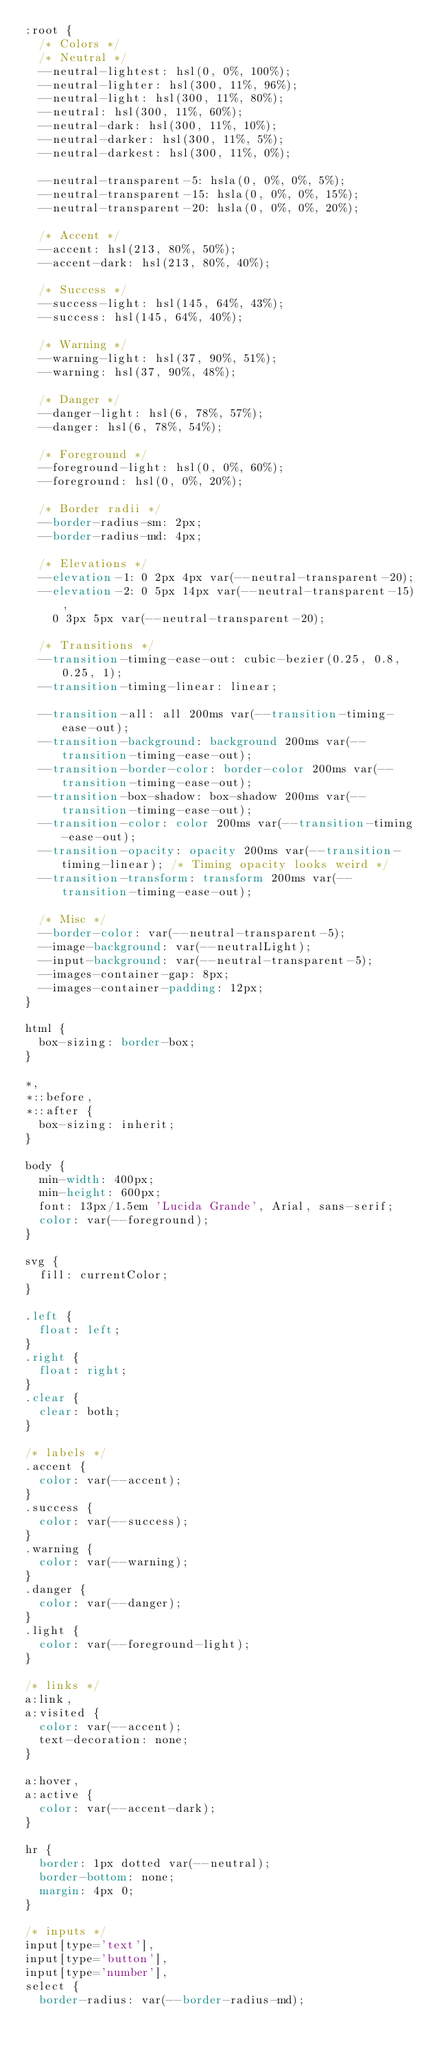Convert code to text. <code><loc_0><loc_0><loc_500><loc_500><_CSS_>:root {
  /* Colors */
  /* Neutral */
  --neutral-lightest: hsl(0, 0%, 100%);
  --neutral-lighter: hsl(300, 11%, 96%);
  --neutral-light: hsl(300, 11%, 80%);
  --neutral: hsl(300, 11%, 60%);
  --neutral-dark: hsl(300, 11%, 10%);
  --neutral-darker: hsl(300, 11%, 5%);
  --neutral-darkest: hsl(300, 11%, 0%);

  --neutral-transparent-5: hsla(0, 0%, 0%, 5%);
  --neutral-transparent-15: hsla(0, 0%, 0%, 15%);
  --neutral-transparent-20: hsla(0, 0%, 0%, 20%);

  /* Accent */
  --accent: hsl(213, 80%, 50%);
  --accent-dark: hsl(213, 80%, 40%);

  /* Success */
  --success-light: hsl(145, 64%, 43%);
  --success: hsl(145, 64%, 40%);

  /* Warning */
  --warning-light: hsl(37, 90%, 51%);
  --warning: hsl(37, 90%, 48%);

  /* Danger */
  --danger-light: hsl(6, 78%, 57%);
  --danger: hsl(6, 78%, 54%);

  /* Foreground */
  --foreground-light: hsl(0, 0%, 60%);
  --foreground: hsl(0, 0%, 20%);

  /* Border radii */
  --border-radius-sm: 2px;
  --border-radius-md: 4px;

  /* Elevations */
  --elevation-1: 0 2px 4px var(--neutral-transparent-20);
  --elevation-2: 0 5px 14px var(--neutral-transparent-15),
    0 3px 5px var(--neutral-transparent-20);

  /* Transitions */
  --transition-timing-ease-out: cubic-bezier(0.25, 0.8, 0.25, 1);
  --transition-timing-linear: linear;

  --transition-all: all 200ms var(--transition-timing-ease-out);
  --transition-background: background 200ms var(--transition-timing-ease-out);
  --transition-border-color: border-color 200ms var(--transition-timing-ease-out);
  --transition-box-shadow: box-shadow 200ms var(--transition-timing-ease-out);
  --transition-color: color 200ms var(--transition-timing-ease-out);
  --transition-opacity: opacity 200ms var(--transition-timing-linear); /* Timing opacity looks weird */
  --transition-transform: transform 200ms var(--transition-timing-ease-out);

  /* Misc */
  --border-color: var(--neutral-transparent-5);
  --image-background: var(--neutralLight);
  --input-background: var(--neutral-transparent-5);
  --images-container-gap: 8px;
  --images-container-padding: 12px;
}

html {
  box-sizing: border-box;
}

*,
*::before,
*::after {
  box-sizing: inherit;
}

body {
  min-width: 400px;
  min-height: 600px;
  font: 13px/1.5em 'Lucida Grande', Arial, sans-serif;
  color: var(--foreground);
}

svg {
  fill: currentColor;
}

.left {
  float: left;
}
.right {
  float: right;
}
.clear {
  clear: both;
}

/* labels */
.accent {
  color: var(--accent);
}
.success {
  color: var(--success);
}
.warning {
  color: var(--warning);
}
.danger {
  color: var(--danger);
}
.light {
  color: var(--foreground-light);
}

/* links */
a:link,
a:visited {
  color: var(--accent);
  text-decoration: none;
}

a:hover,
a:active {
  color: var(--accent-dark);
}

hr {
  border: 1px dotted var(--neutral);
  border-bottom: none;
  margin: 4px 0;
}

/* inputs */
input[type='text'],
input[type='button'],
input[type='number'],
select {
  border-radius: var(--border-radius-md);</code> 